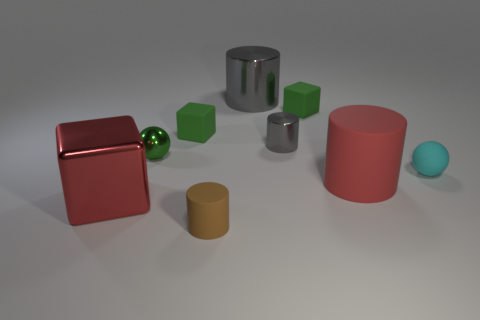What material is the cylinder that is the same color as the large block?
Make the answer very short. Rubber. Do the cyan matte ball and the metallic ball have the same size?
Make the answer very short. Yes. There is a tiny gray thing that is the same shape as the large gray metal object; what is its material?
Your answer should be compact. Metal. How many other metallic cylinders have the same size as the red cylinder?
Keep it short and to the point. 1. The tiny object that is made of the same material as the green sphere is what color?
Your response must be concise. Gray. Are there fewer big cubes than cylinders?
Offer a very short reply. Yes. How many brown things are tiny spheres or matte things?
Keep it short and to the point. 1. How many objects are left of the red matte object and behind the large red rubber thing?
Ensure brevity in your answer.  5. Does the large gray cylinder have the same material as the tiny gray cylinder?
Provide a succinct answer. Yes. The other red object that is the same size as the red matte thing is what shape?
Ensure brevity in your answer.  Cube. 